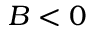Convert formula to latex. <formula><loc_0><loc_0><loc_500><loc_500>B < 0</formula> 